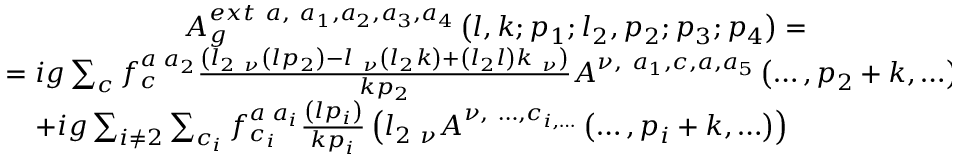<formula> <loc_0><loc_0><loc_500><loc_500>\begin{array} { c } { { A _ { g } ^ { e x t \ a , \ a _ { 1 } , a _ { 2 } , a _ { 3 } , a _ { 4 } } \left ( l , k ; p _ { 1 } ; l _ { 2 } , p _ { 2 } ; p _ { 3 } ; p _ { 4 } \right ) = } } \\ { { = i g \sum _ { c } f _ { c } ^ { a \, a _ { 2 } } \frac { \left ( l _ { 2 \ \nu } \left ( l p _ { 2 } \right ) - l _ { \ \nu } \left ( l _ { 2 } k \right ) + \left ( l _ { 2 } l \right ) k _ { \ \nu } \right ) } { k p _ { 2 } } A ^ { \nu , \ a _ { 1 } , c , a , a _ { 5 } } \left ( \dots , p _ { 2 } + k , \dots \right ) + } } \\ { { + i g \sum _ { i \neq 2 } \sum _ { c _ { i } } f _ { c _ { i } } ^ { a \, a _ { i } } \frac { \left ( l p _ { i } \right ) } { k p _ { i } } \left ( l _ { 2 \ \nu } A ^ { \nu , \ \dots , c _ { i , \dots } } \left ( \dots , p _ { i } + k , \dots \right ) \right ) \quad } } \end{array}</formula> 